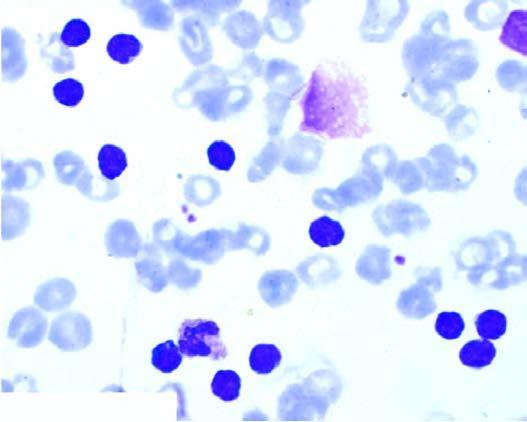s there large excess of mature and small differentiated lymphocytes?
Answer the question using a single word or phrase. Yes 